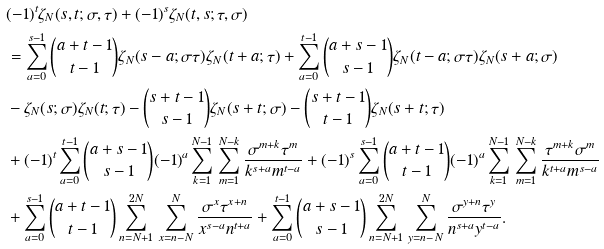<formula> <loc_0><loc_0><loc_500><loc_500>& ( - 1 ) ^ { t } \zeta _ { N } ( s , t ; \sigma , \tau ) + ( - 1 ) ^ { s } \zeta _ { N } ( t , s ; \tau , \sigma ) \\ & = \sum _ { a = 0 } ^ { s - 1 } \binom { a + t - 1 } { t - 1 } \zeta _ { N } ( s - a ; \sigma \tau ) \zeta _ { N } ( t + a ; \tau ) + \sum _ { a = 0 } ^ { t - 1 } \binom { a + s - 1 } { s - 1 } \zeta _ { N } ( t - a ; \sigma \tau ) \zeta _ { N } ( s + a ; \sigma ) \\ & - \zeta _ { N } ( s ; \sigma ) \zeta _ { N } ( t ; \tau ) - \binom { s + t - 1 } { s - 1 } \zeta _ { N } ( s + t ; \sigma ) - \binom { s + t - 1 } { t - 1 } \zeta _ { N } ( s + t ; \tau ) \\ & + ( - 1 ) ^ { t } \sum _ { a = 0 } ^ { t - 1 } \binom { a + s - 1 } { s - 1 } ( - 1 ) ^ { a } \sum _ { k = 1 } ^ { N - 1 } \, \sum _ { m = 1 } ^ { N - k } \frac { \sigma ^ { m + k } \tau ^ { m } } { k ^ { s + a } m ^ { t - a } } + ( - 1 ) ^ { s } \sum _ { a = 0 } ^ { s - 1 } \binom { a + t - 1 } { t - 1 } ( - 1 ) ^ { a } \sum _ { k = 1 } ^ { N - 1 } \, \sum _ { m = 1 } ^ { N - k } \frac { \tau ^ { m + k } \sigma ^ { m } } { k ^ { t + a } m ^ { s - a } } \\ & + \sum _ { a = 0 } ^ { s - 1 } \binom { a + t - 1 } { t - 1 } \sum _ { n = N + 1 } ^ { 2 N } \, \sum _ { x = n - N } ^ { N } \frac { \sigma ^ { x } \tau ^ { x + n } } { x ^ { s - a } n ^ { t + a } } + \sum _ { a = 0 } ^ { t - 1 } \binom { a + s - 1 } { s - 1 } \sum _ { n = N + 1 } ^ { 2 N } \, \sum _ { y = n - N } ^ { N } \frac { \sigma ^ { y + n } \tau ^ { y } } { n ^ { s + a } y ^ { t - a } } .</formula> 